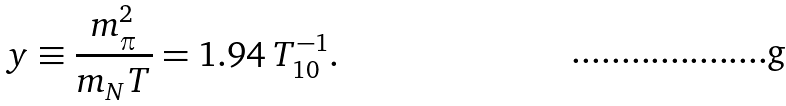<formula> <loc_0><loc_0><loc_500><loc_500>y \equiv \frac { m _ { \pi } ^ { 2 } } { m _ { N } T } = 1 . 9 4 \, T _ { 1 0 } ^ { - 1 } .</formula> 